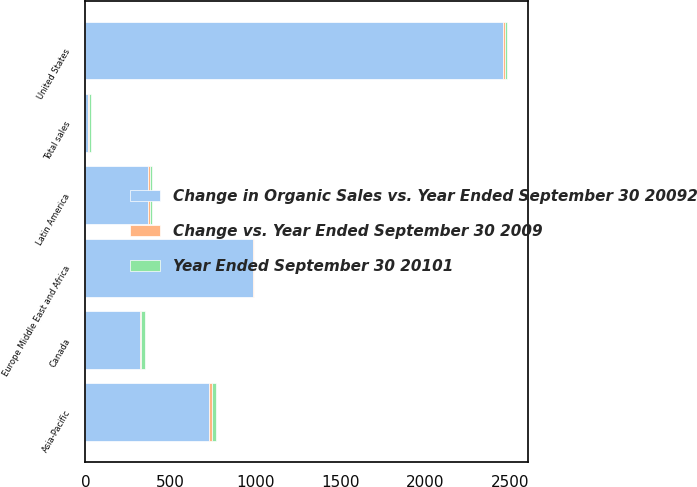Convert chart. <chart><loc_0><loc_0><loc_500><loc_500><stacked_bar_chart><ecel><fcel>United States<fcel>Canada<fcel>Europe Middle East and Africa<fcel>Asia-Pacific<fcel>Latin America<fcel>Total sales<nl><fcel>Change in Organic Sales vs. Year Ended September 30 20092<fcel>2456.2<fcel>321<fcel>987.3<fcel>724.3<fcel>368.2<fcel>13<nl><fcel>Year Ended September 30 20101<fcel>11<fcel>25<fcel>3<fcel>25<fcel>13<fcel>12<nl><fcel>Change vs. Year Ended September 30 2009<fcel>11<fcel>7<fcel>2<fcel>17<fcel>11<fcel>10<nl></chart> 